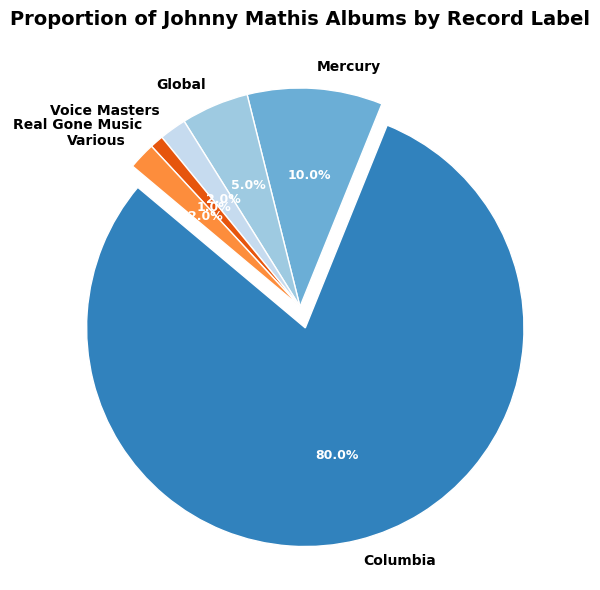What percentage of Johnny Mathis albums were released under Columbia? The largest slice of the pie chart is for Columbia, which is indicated to have 80% of the albums. Just look at the label percentages on the chart.
Answer: 80% Which two labels have the smallest proportions of Johnny Mathis albums? By examining the smallest slices on the pie chart, Real Gone Music and Voice Masters have the smallest proportions of 1% and 2%, respectively.
Answer: Real Gone Music and Voice Masters What is the combined percentage of albums released by Mercury, Global, and Various? Add the percentages for Mercury (10%), Global (5%), and Various (2%). The combined percentage is 10 + 5 + 2 = 17%.
Answer: 17% Is the proportion of albums released by Columbia greater than the proportion of albums released by all other labels combined? Sum the percentages of all labels except Columbia: Mercury (10%) + Global (5%) + Voice Masters (2%) + Real Gone Music (1%) + Various (2%) = 20%. Compare this with Columbia (80%). Columbia's 80% is greater than 20%.
Answer: Yes What is the difference between the proportions of albums released by Columbia and Mercury? Subtract Mercury's percentage (10%) from Columbia's percentage (80%): 80 - 10 = 70%.
Answer: 70% How many record labels have proportions of 5% or higher? Identify the labels with 5% or higher proportions: Columbia (80%), Mercury (10%), and Global (5%). There are three labels with 5% or higher.
Answer: 3 Which label has the largest slice in the pie chart, and by how much percentage is it larger than the next largest slice? Columbia has the largest slice (80%). The next largest slice is Mercury (10%). The difference is 80 - 10 = 70%.
Answer: Columbia, 70% What is the proportion of albums released by labels other than Columbia? Add the percentages of all labels except Columbia: 10% (Mercury) + 5% (Global) + 2% (Voice Masters) + 1% (Real Gone Music) + 2% (Various) = 20%.
Answer: 20% If Voice Masters and Real Gone Music were merged, what would be their combined proportion of Johnny Mathis albums? Add the proportions of Voice Masters (2%) and Real Gone Music (1%): 2 + 1 = 3%.
Answer: 3% What color is used for the slice representing Johnny Mathis albums released under Global? The color for Global's slice can be identified visually from the pie chart. Based on the color scheme, it is the fourth largest pie slice and likely has a distinct color.
Answer: [Please look at the pie chart for the color] 